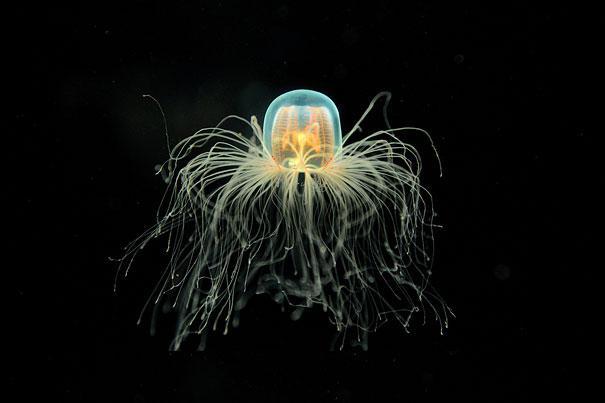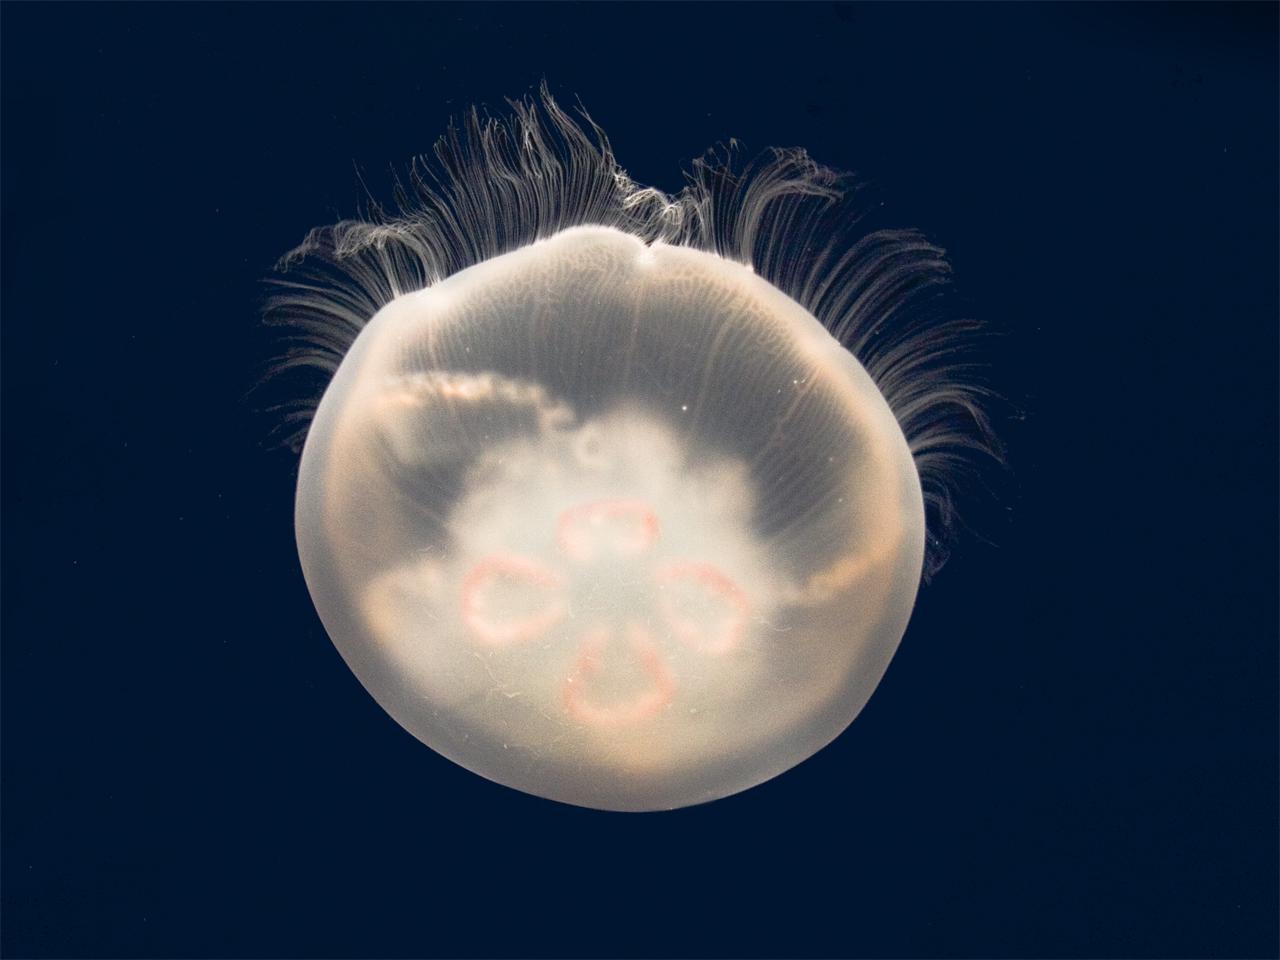The first image is the image on the left, the second image is the image on the right. Analyze the images presented: Is the assertion "In at least one image there is a small jelly fish with 4 leaf patterned legs float upwards." valid? Answer yes or no. No. The first image is the image on the left, the second image is the image on the right. Analyze the images presented: Is the assertion "Each of the images shows a single jellyfish that has been photographed in a dark part of ocean where there is little or no light." valid? Answer yes or no. Yes. 